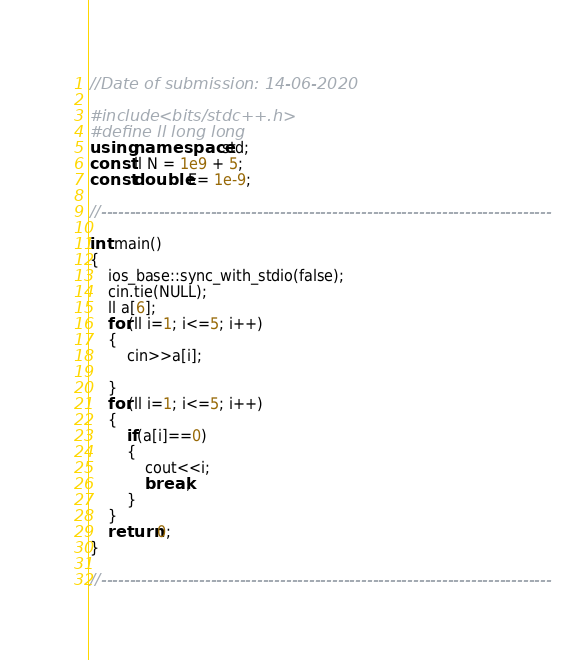Convert code to text. <code><loc_0><loc_0><loc_500><loc_500><_C++_>//Date of submission: 14-06-2020

#include <bits/stdc++.h>
#define ll long long
using namespace std;
const ll N = 1e9 + 5;
const double E= 1e-9;

//------------------------------------------------------------------------------

int main()
{
    ios_base::sync_with_stdio(false);
    cin.tie(NULL);
    ll a[6];
    for(ll i=1; i<=5; i++)
    {
        cin>>a[i];
        
    }   
    for(ll i=1; i<=5; i++)
    {
        if(a[i]==0)
        {
            cout<<i;
            break;
        }
    }
    return 0;
}

//------------------------------------------------------------------------------
</code> 